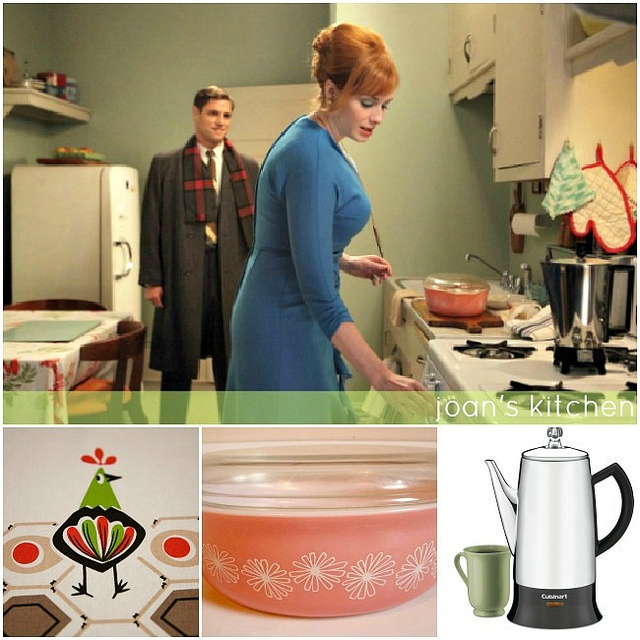Describe the objects in this image and their specific colors. I can see people in white, blue, olive, and darkblue tones, bowl in white, tan, and salmon tones, people in white, black, maroon, gray, and tan tones, refrigerator in white, tan, khaki, and lightyellow tones, and oven in white, khaki, olive, black, and tan tones in this image. 